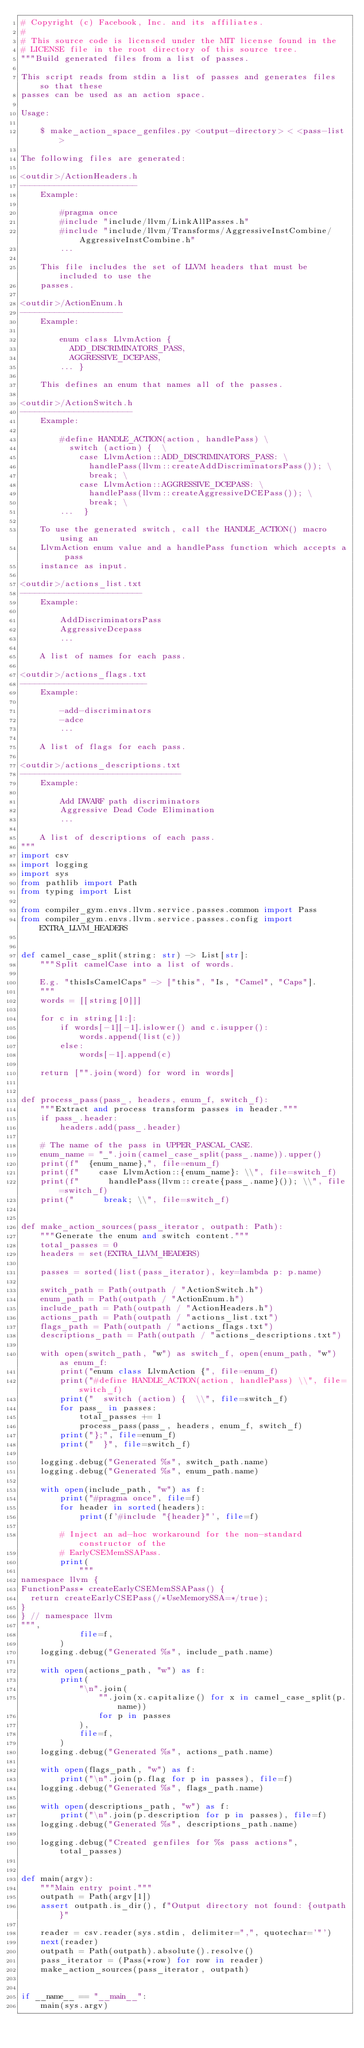<code> <loc_0><loc_0><loc_500><loc_500><_Python_># Copyright (c) Facebook, Inc. and its affiliates.
#
# This source code is licensed under the MIT license found in the
# LICENSE file in the root directory of this source tree.
"""Build generated files from a list of passes.

This script reads from stdin a list of passes and generates files so that these
passes can be used as an action space.

Usage:

    $ make_action_space_genfiles.py <output-directory> < <pass-list>

The following files are generated:

<outdir>/ActionHeaders.h
------------------------
    Example:

        #pragma once
        #include "include/llvm/LinkAllPasses.h"
        #include "include/llvm/Transforms/AggressiveInstCombine/AggressiveInstCombine.h"
        ...

    This file includes the set of LLVM headers that must be included to use the
    passes.

<outdir>/ActionEnum.h
---------------------
    Example:

        enum class LlvmAction {
          ADD_DISCRIMINATORS_PASS,
          AGGRESSIVE_DCEPASS,
        ... }

    This defines an enum that names all of the passes.

<outdir>/ActionSwitch.h
-----------------------
    Example:

        #define HANDLE_ACTION(action, handlePass) \
          switch (action) {  \
            case LlvmAction::ADD_DISCRIMINATORS_PASS: \
              handlePass(llvm::createAddDiscriminatorsPass()); \
              break; \
            case LlvmAction::AGGRESSIVE_DCEPASS: \
              handlePass(llvm::createAggressiveDCEPass()); \
              break; \
        ...  }

    To use the generated switch, call the HANDLE_ACTION() macro using an
    LlvmAction enum value and a handlePass function which accepts a pass
    instance as input.

<outdir>/actions_list.txt
-------------------------
    Example:

        AddDiscriminatorsPass
        AggressiveDcepass
        ...

    A list of names for each pass.

<outdir>/actions_flags.txt
--------------------------
    Example:

        -add-discriminators
        -adce
        ...

    A list of flags for each pass.

<outdir>/actions_descriptions.txt
---------------------------------
    Example:

        Add DWARF path discriminators
        Aggressive Dead Code Elimination
        ...

    A list of descriptions of each pass.
"""
import csv
import logging
import sys
from pathlib import Path
from typing import List

from compiler_gym.envs.llvm.service.passes.common import Pass
from compiler_gym.envs.llvm.service.passes.config import EXTRA_LLVM_HEADERS


def camel_case_split(string: str) -> List[str]:
    """Split camelCase into a list of words.

    E.g. "thisIsCamelCaps" -> ["this", "Is, "Camel", "Caps"].
    """
    words = [[string[0]]]

    for c in string[1:]:
        if words[-1][-1].islower() and c.isupper():
            words.append(list(c))
        else:
            words[-1].append(c)

    return ["".join(word) for word in words]


def process_pass(pass_, headers, enum_f, switch_f):
    """Extract and process transform passes in header."""
    if pass_.header:
        headers.add(pass_.header)

    # The name of the pass in UPPER_PASCAL_CASE.
    enum_name = "_".join(camel_case_split(pass_.name)).upper()
    print(f"  {enum_name},", file=enum_f)
    print(f"    case LlvmAction::{enum_name}: \\", file=switch_f)
    print(f"      handlePass(llvm::create{pass_.name}()); \\", file=switch_f)
    print("      break; \\", file=switch_f)


def make_action_sources(pass_iterator, outpath: Path):
    """Generate the enum and switch content."""
    total_passes = 0
    headers = set(EXTRA_LLVM_HEADERS)

    passes = sorted(list(pass_iterator), key=lambda p: p.name)

    switch_path = Path(outpath / "ActionSwitch.h")
    enum_path = Path(outpath / "ActionEnum.h")
    include_path = Path(outpath / "ActionHeaders.h")
    actions_path = Path(outpath / "actions_list.txt")
    flags_path = Path(outpath / "actions_flags.txt")
    descriptions_path = Path(outpath / "actions_descriptions.txt")

    with open(switch_path, "w") as switch_f, open(enum_path, "w") as enum_f:
        print("enum class LlvmAction {", file=enum_f)
        print("#define HANDLE_ACTION(action, handlePass) \\", file=switch_f)
        print("  switch (action) {  \\", file=switch_f)
        for pass_ in passes:
            total_passes += 1
            process_pass(pass_, headers, enum_f, switch_f)
        print("};", file=enum_f)
        print("  }", file=switch_f)

    logging.debug("Generated %s", switch_path.name)
    logging.debug("Generated %s", enum_path.name)

    with open(include_path, "w") as f:
        print("#pragma once", file=f)
        for header in sorted(headers):
            print(f'#include "{header}"', file=f)

        # Inject an ad-hoc workaround for the non-standard constructor of the
        # EarlyCSEMemSSAPass.
        print(
            """
namespace llvm {
FunctionPass* createEarlyCSEMemSSAPass() {
  return createEarlyCSEPass(/*UseMemorySSA=*/true);
}
} // namespace llvm
""",
            file=f,
        )
    logging.debug("Generated %s", include_path.name)

    with open(actions_path, "w") as f:
        print(
            "\n".join(
                "".join(x.capitalize() for x in camel_case_split(p.name))
                for p in passes
            ),
            file=f,
        )
    logging.debug("Generated %s", actions_path.name)

    with open(flags_path, "w") as f:
        print("\n".join(p.flag for p in passes), file=f)
    logging.debug("Generated %s", flags_path.name)

    with open(descriptions_path, "w") as f:
        print("\n".join(p.description for p in passes), file=f)
    logging.debug("Generated %s", descriptions_path.name)

    logging.debug("Created genfiles for %s pass actions", total_passes)


def main(argv):
    """Main entry point."""
    outpath = Path(argv[1])
    assert outpath.is_dir(), f"Output directory not found: {outpath}"

    reader = csv.reader(sys.stdin, delimiter=",", quotechar='"')
    next(reader)
    outpath = Path(outpath).absolute().resolve()
    pass_iterator = (Pass(*row) for row in reader)
    make_action_sources(pass_iterator, outpath)


if __name__ == "__main__":
    main(sys.argv)
</code> 